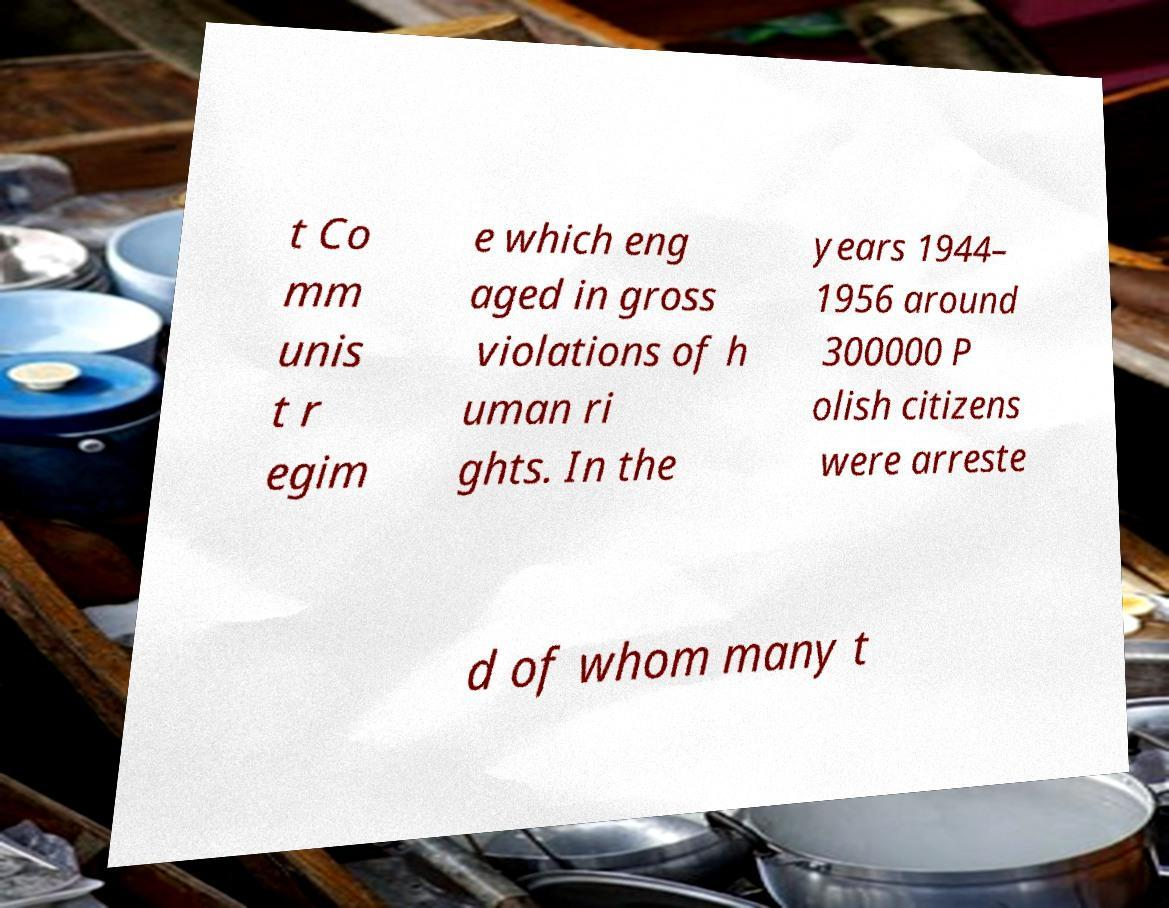Could you assist in decoding the text presented in this image and type it out clearly? t Co mm unis t r egim e which eng aged in gross violations of h uman ri ghts. In the years 1944– 1956 around 300000 P olish citizens were arreste d of whom many t 